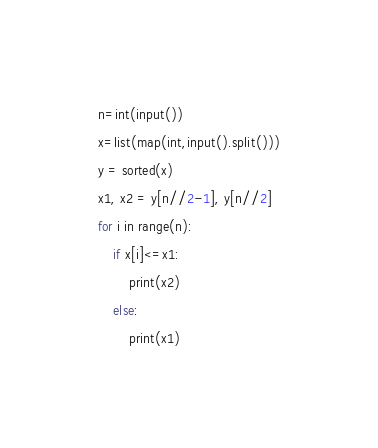Convert code to text. <code><loc_0><loc_0><loc_500><loc_500><_Python_>n=int(input())
x=list(map(int,input().split()))
y = sorted(x)
x1, x2 = y[n//2-1], y[n//2]
for i in range(n):
    if x[i]<=x1:
        print(x2)
    else:
        print(x1)
</code> 